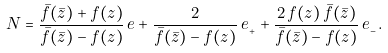Convert formula to latex. <formula><loc_0><loc_0><loc_500><loc_500>N = \frac { \bar { f } ( \bar { z } ) + f ( z ) } { \bar { f } ( \bar { z } ) - f ( z ) } \, { e } + \frac { 2 } { \bar { f } ( \bar { z } ) - f ( z ) } \, { e } _ { _ { + } } + \frac { 2 \, f ( z ) \, \bar { f } ( \bar { z } ) } { \bar { f } ( \bar { z } ) - f ( z ) } \, { e } _ { _ { - } } .</formula> 